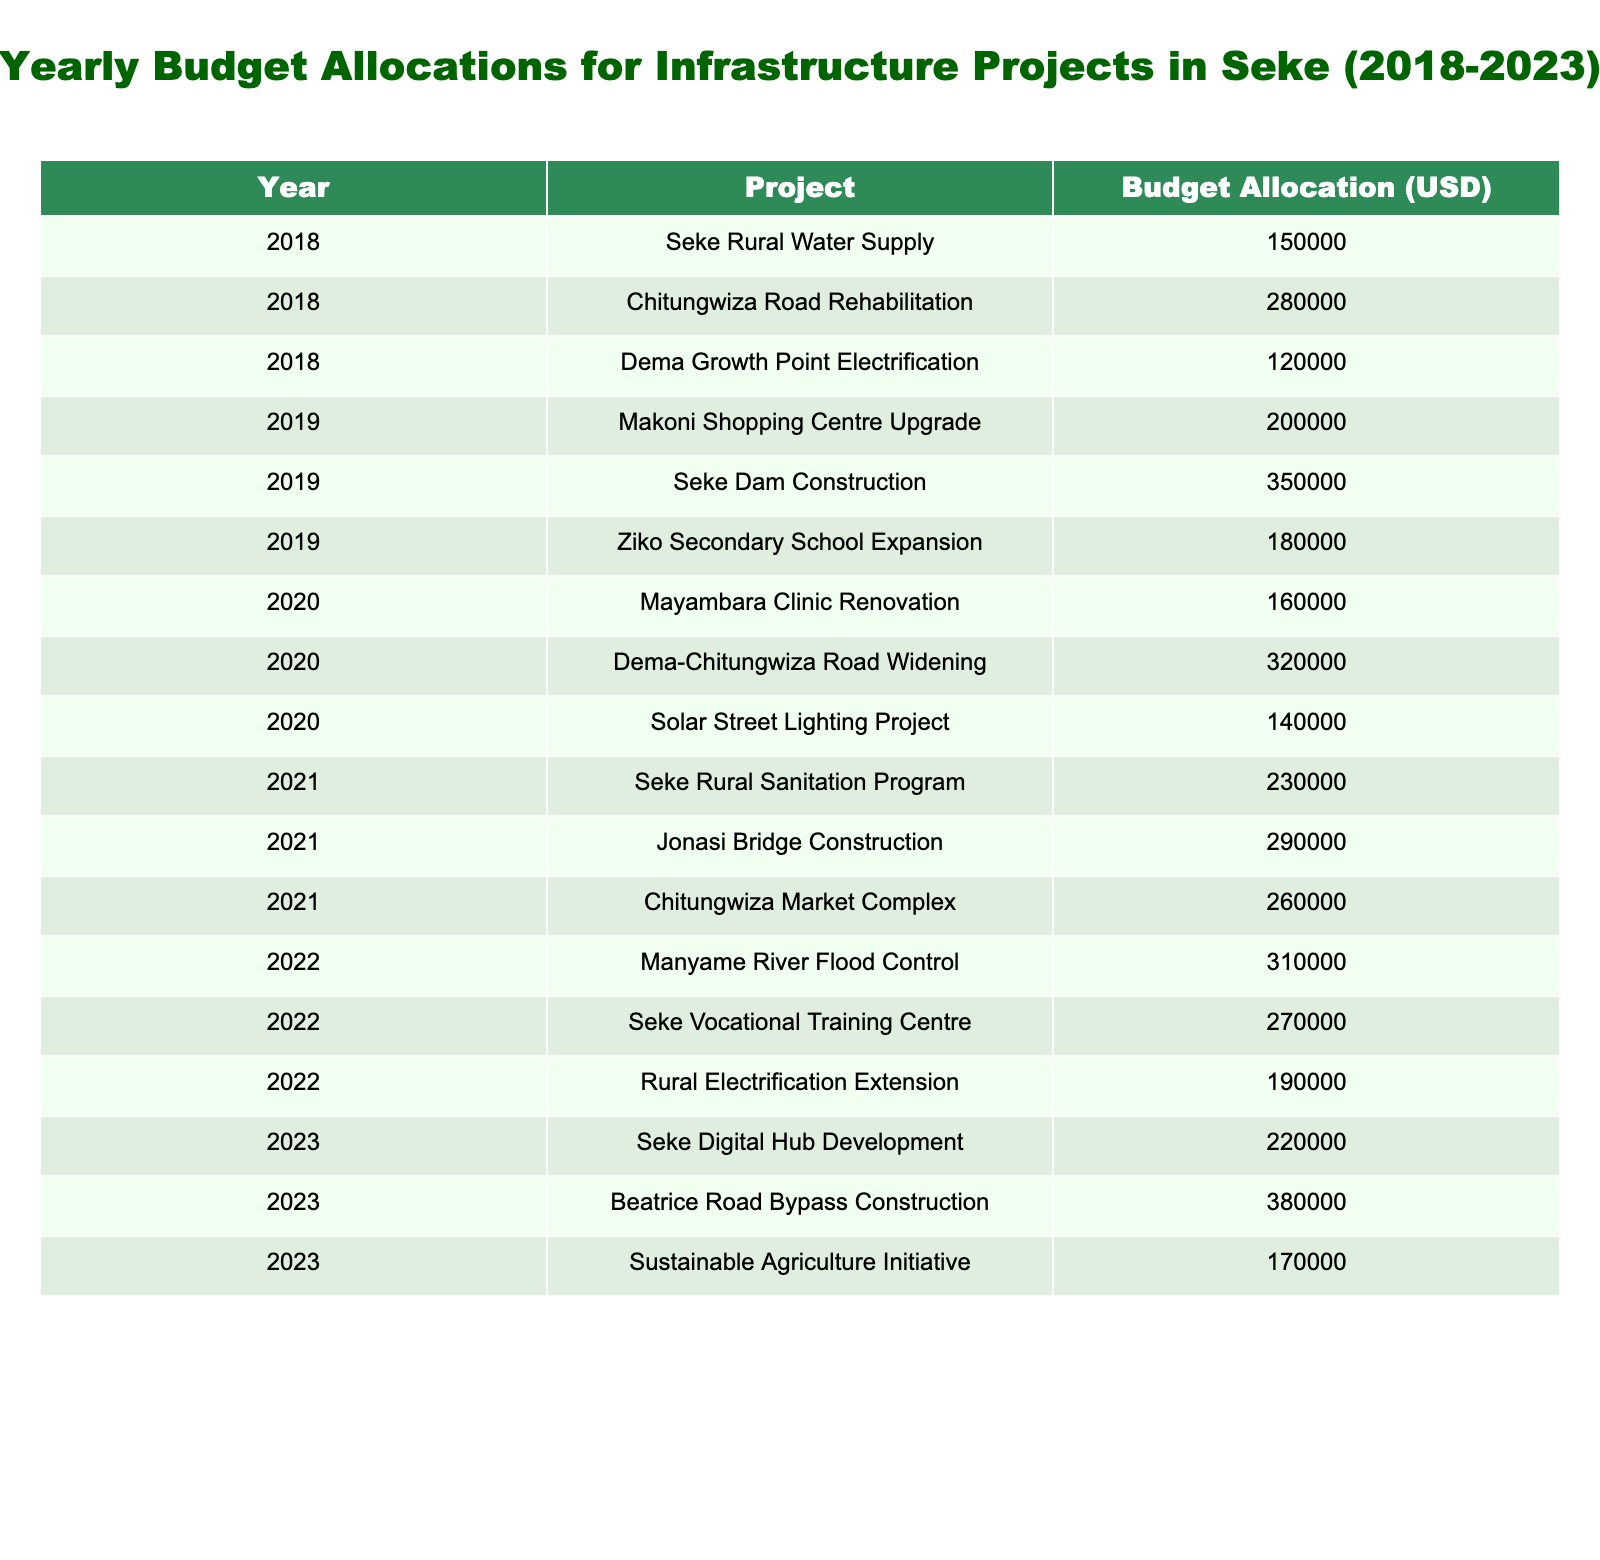What was the budget allocation for Seke Rural Water Supply in 2018? The table shows that the budget allocation for Seke Rural Water Supply in 2018 is listed directly under that project, which is 150,000 USD.
Answer: 150000 USD Which project had the highest budget allocation in 2023? In the year 2023, when reviewing the budget allocations for each project, Beatrice Road Bypass Construction has the highest allocation of 380,000 USD.
Answer: Beatrice Road Bypass Construction What was the total budget allocation for infrastructure projects in 2020? To find the total for 2020, sum the budget allocations for all projects listed in that year: 160,000 + 320,000 + 140,000 = 620,000 USD.
Answer: 620000 USD How many infrastructure projects had budgets over 250,000 USD in 2019? In 2019, there are three projects, Seke Dam Construction (350,000 USD) and Makoni Shopping Centre Upgrade (200,000 USD) with budgets above 250,000 USD. Thus, the total count is 2.
Answer: 2 What is the average budget allocation for projects across all years? First, sum all budget allocations from 2018 to 2023, which equals 3,090,000 USD, then divide by the total number of projects (12), resulting in an average allocation of approximately 257,500 USD.
Answer: 257500 USD Was there a project in 2021 that received a higher budget than the Seke Vocational Training Centre in 2022? The budget allocation for the Seke Vocational Training Centre in 2022 is 270,000 USD. In 2021, the highest allocation was for Jonasi Bridge Construction at 290,000 USD, which is higher than 270,000 USD.
Answer: Yes Which year had the lowest total budget allocation across all projects? Calculate the total allocations for each year: 2018 (550,000 USD), 2019 (730,000 USD), 2020 (620,000 USD), 2021 (780,000 USD), 2022 (770,000 USD), and 2023 (780,000 USD). The lowest total is in 2018.
Answer: 2018 How much more was allocated to Chitungwiza Road Rehabilitation compared to Manyame River Flood Control? Chitungwiza Road Rehabilitation was allocated 280,000 USD, while Manyame River Flood Control received 310,000 USD. The difference is calculated as 310,000 - 280,000 = 30,000 USD.
Answer: 30000 USD What percentage of the total budget allocation from 2018 to 2023 was spent on the Seke Dam Construction project? The total budget allocation across all years is 3,090,000 USD, and the budget for Seke Dam Construction is 350,000 USD. Calculate the percentage as (350,000 / 3,090,000) * 100 ≈ 11.32%.
Answer: Approximately 11.32% Was there a project in 2019 that had a budget allocation equal to 200,000 USD? Checking the 2019 projects, the Makoni Shopping Centre Upgrade is allocated exactly 200,000 USD, confirming the fact.
Answer: Yes 